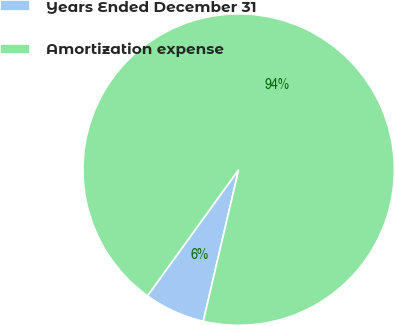Convert chart. <chart><loc_0><loc_0><loc_500><loc_500><pie_chart><fcel>Years Ended December 31<fcel>Amortization expense<nl><fcel>6.31%<fcel>93.69%<nl></chart> 